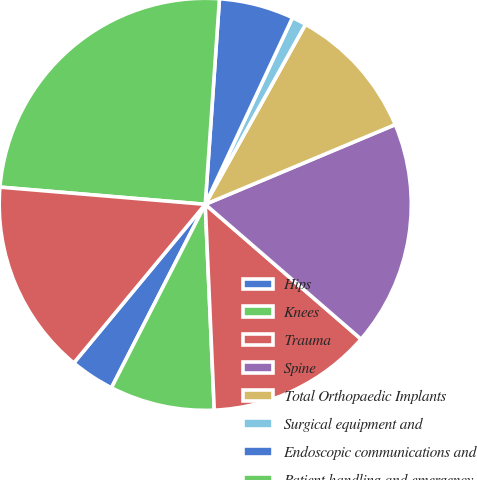Convert chart to OTSL. <chart><loc_0><loc_0><loc_500><loc_500><pie_chart><fcel>Hips<fcel>Knees<fcel>Trauma<fcel>Spine<fcel>Total Orthopaedic Implants<fcel>Surgical equipment and<fcel>Endoscopic communications and<fcel>Patient handling and emergency<fcel>Total MedSurg Equipment<nl><fcel>3.49%<fcel>8.22%<fcel>12.95%<fcel>17.68%<fcel>10.59%<fcel>1.13%<fcel>5.86%<fcel>24.77%<fcel>15.32%<nl></chart> 